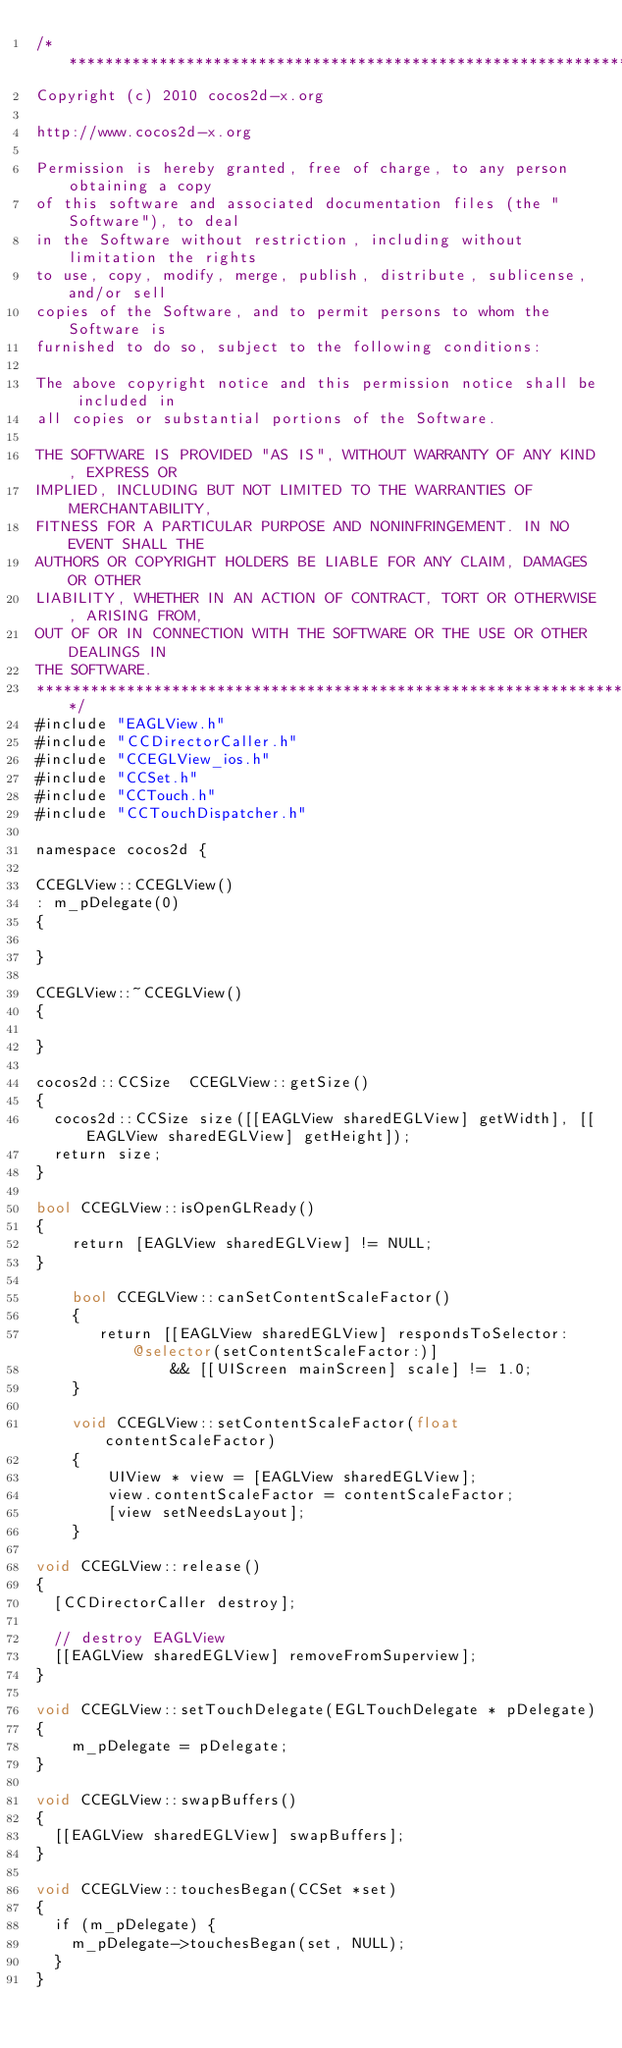Convert code to text. <code><loc_0><loc_0><loc_500><loc_500><_ObjectiveC_>/****************************************************************************
Copyright (c) 2010 cocos2d-x.org

http://www.cocos2d-x.org

Permission is hereby granted, free of charge, to any person obtaining a copy
of this software and associated documentation files (the "Software"), to deal
in the Software without restriction, including without limitation the rights
to use, copy, modify, merge, publish, distribute, sublicense, and/or sell
copies of the Software, and to permit persons to whom the Software is
furnished to do so, subject to the following conditions:

The above copyright notice and this permission notice shall be included in
all copies or substantial portions of the Software.

THE SOFTWARE IS PROVIDED "AS IS", WITHOUT WARRANTY OF ANY KIND, EXPRESS OR
IMPLIED, INCLUDING BUT NOT LIMITED TO THE WARRANTIES OF MERCHANTABILITY,
FITNESS FOR A PARTICULAR PURPOSE AND NONINFRINGEMENT. IN NO EVENT SHALL THE
AUTHORS OR COPYRIGHT HOLDERS BE LIABLE FOR ANY CLAIM, DAMAGES OR OTHER
LIABILITY, WHETHER IN AN ACTION OF CONTRACT, TORT OR OTHERWISE, ARISING FROM,
OUT OF OR IN CONNECTION WITH THE SOFTWARE OR THE USE OR OTHER DEALINGS IN
THE SOFTWARE.
****************************************************************************/
#include "EAGLView.h"
#include "CCDirectorCaller.h"
#include "CCEGLView_ios.h"
#include "CCSet.h"
#include "CCTouch.h"
#include "CCTouchDispatcher.h"

namespace cocos2d {

CCEGLView::CCEGLView()
: m_pDelegate(0)
{

}

CCEGLView::~CCEGLView()
{

}

cocos2d::CCSize  CCEGLView::getSize()
{
	cocos2d::CCSize size([[EAGLView sharedEGLView] getWidth], [[EAGLView sharedEGLView] getHeight]);
	return size;
}

bool CCEGLView::isOpenGLReady()
{
    return [EAGLView sharedEGLView] != NULL;
}
    
    bool CCEGLView::canSetContentScaleFactor()
    {
       return [[EAGLView sharedEGLView] respondsToSelector:@selector(setContentScaleFactor:)]
               && [[UIScreen mainScreen] scale] != 1.0;
    }
    
    void CCEGLView::setContentScaleFactor(float contentScaleFactor)
    {
        UIView * view = [EAGLView sharedEGLView];
        view.contentScaleFactor = contentScaleFactor;
        [view setNeedsLayout];
    }

void CCEGLView::release()
{
	[CCDirectorCaller destroy];
	
	// destroy EAGLView
	[[EAGLView sharedEGLView] removeFromSuperview];
}

void CCEGLView::setTouchDelegate(EGLTouchDelegate * pDelegate)
{
    m_pDelegate = pDelegate;
}

void CCEGLView::swapBuffers()
{
	[[EAGLView sharedEGLView] swapBuffers];
}
	
void CCEGLView::touchesBegan(CCSet *set)
{
	if (m_pDelegate) {
		m_pDelegate->touchesBegan(set, NULL);
	}
}
</code> 